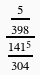Convert formula to latex. <formula><loc_0><loc_0><loc_500><loc_500>\frac { \frac { 5 } { 3 9 8 } } { \frac { 1 4 1 ^ { 5 } } { 3 0 4 } }</formula> 